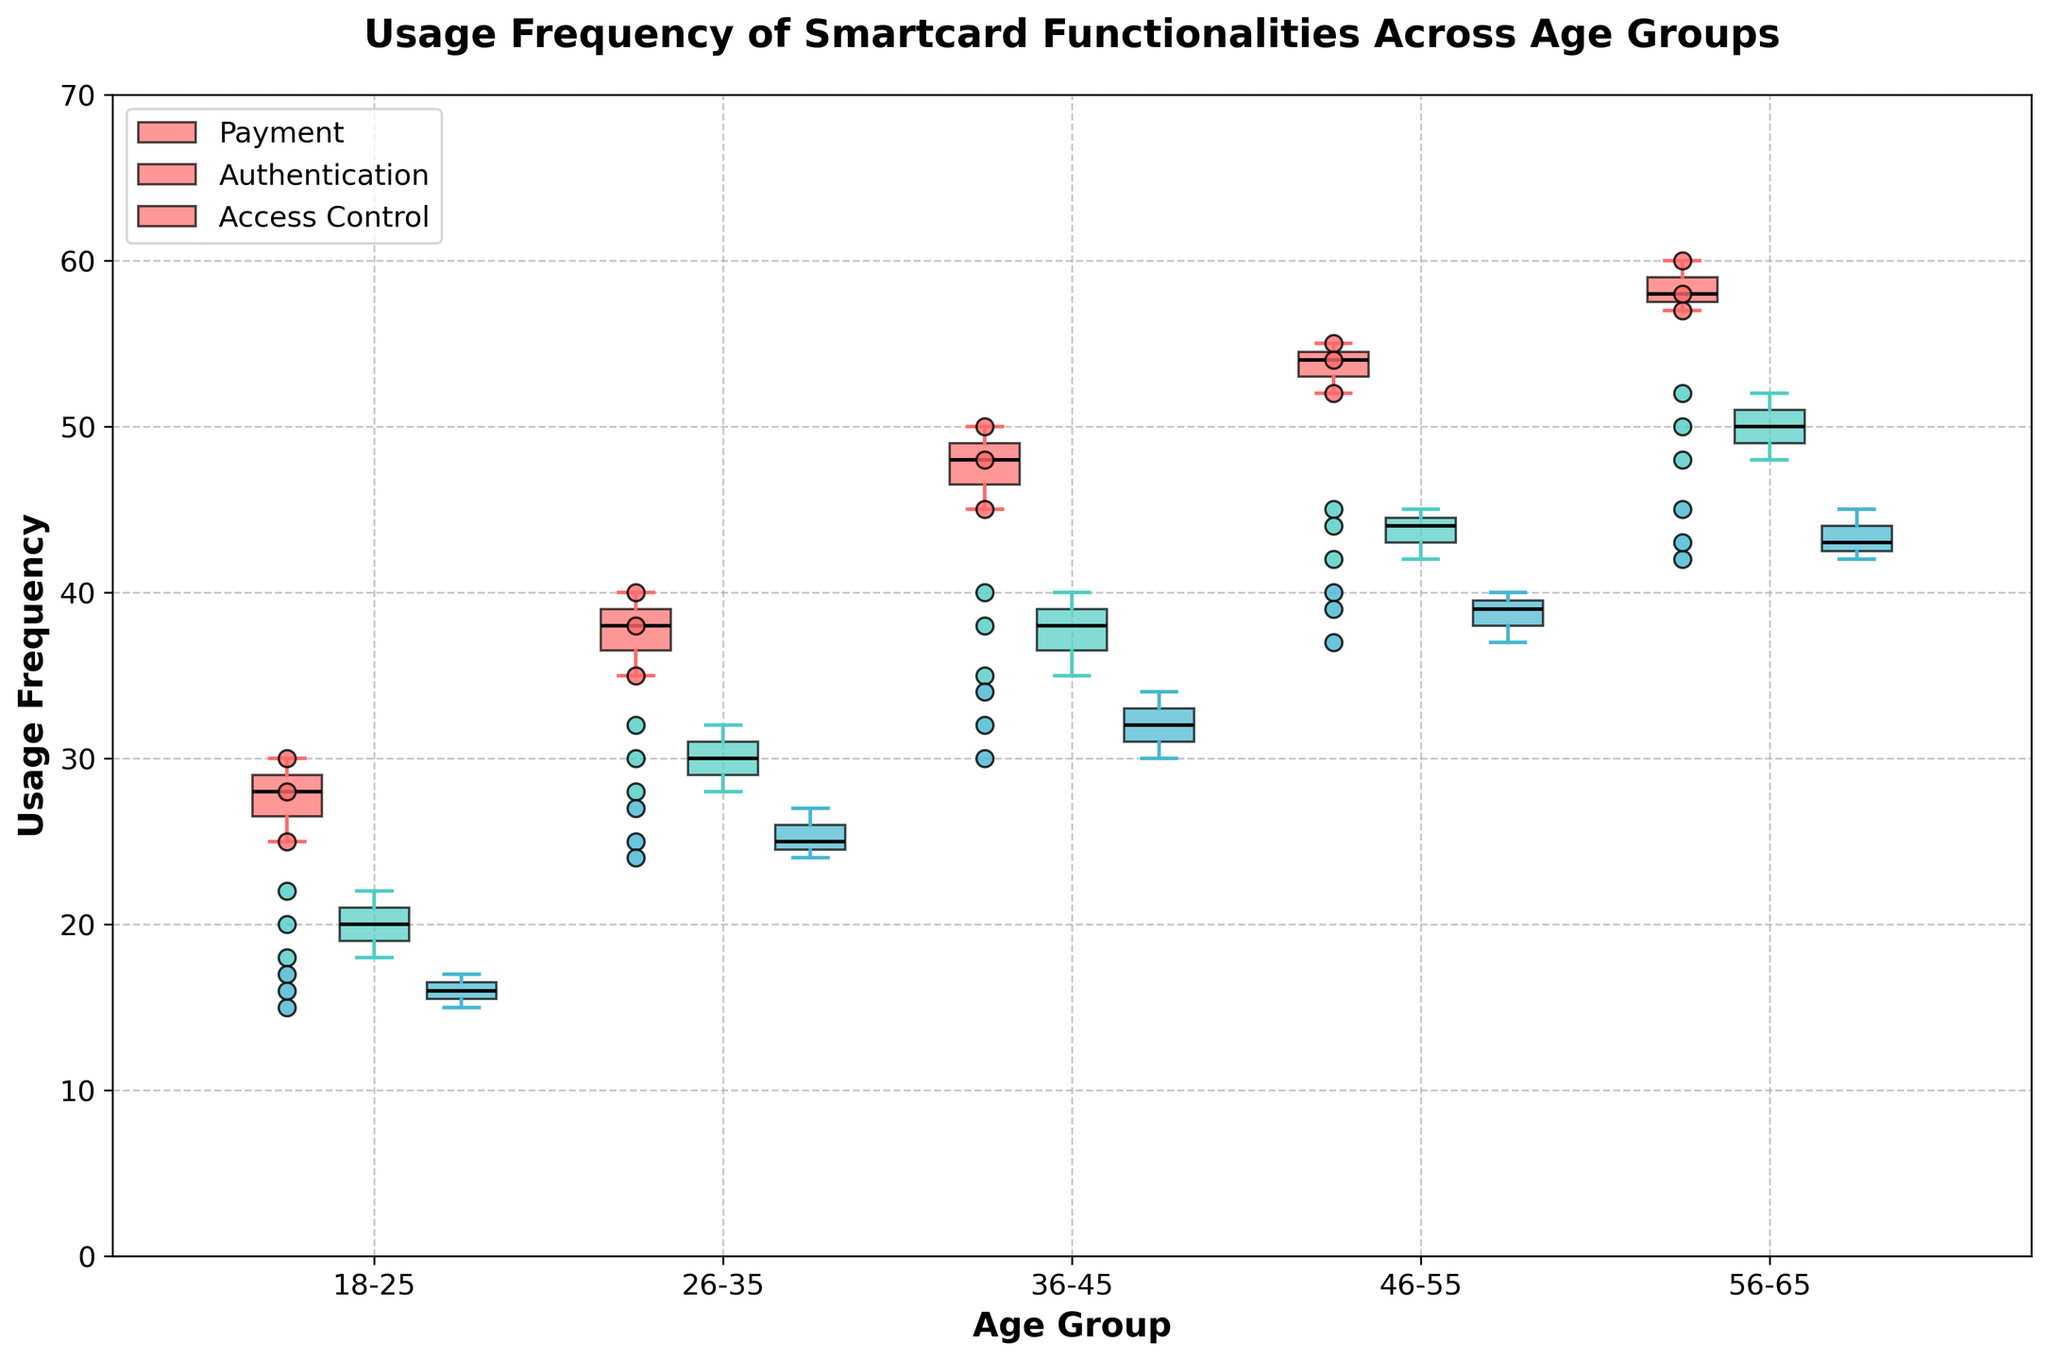What age group has the highest median usage frequency for Payments? In the box plot, the position of the median line within each box indicates the median value. By comparing the median lines for Payments across different age groups, you can identify that the 56-65 age group has the highest median usage frequency.
Answer: 56-65 What's the average range of usage frequency for Authentication in the 46-55 age group? The range is given by the difference between the maximum and minimum values. For Authentication in the 46-55 age group, the maximum value is 45, and the minimum value is 42. So, the range is 45 - 42 = 3.
Answer: 3 Compare the median usage frequencies of Payment and Authentication functionalities for the age group 26-35. Which is higher? For the 26-35 age group, look at the position of the median lines within the box plots for both Payment and Authentication functionalities. The Payment's median value is higher than that of Authentication.
Answer: Payment Which functionality has the most consistent usage frequency in the 36-45 age group? Consistency is indicated by the smallest interquartile range (IQR). For the 36-45 age group, the Access Control box has the smallest IQR, indicating it is the most consistent.
Answer: Access Control How do the median usage frequencies for Access Control change across age groups? Observe the position of the median lines within the Access Control boxes across all age groups. The median usage frequency increases as the age groups progress from 18-25 to 56-65.
Answer: Increases What is the median usage frequency for Payment in the 18-25 age group, and how does it compare with Authentication in the same age group? The median line within the box for Payment in the 18-25 age group is at 28. For Authentication, the median is at 20. Comparing these, the median for Payment is higher.
Answer: Payment: 30, Authentication: 20 - Payment is higher Does any functionality in any age group overlap entirely with another functionality's range? Overlap is indicated by comparing the whiskers (minimum and maximum values). For instance, in the 18-25 age group, the complete range of Access Control overlaps with the lower part of Payment and Authentication ranges.
Answer: Yes, Access Control in the 18-25 age group overlaps with Payment and Authentication ranges 